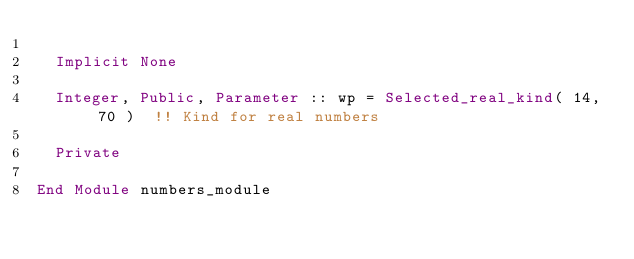<code> <loc_0><loc_0><loc_500><loc_500><_FORTRAN_>  
  Implicit None 
  
  Integer, Public, Parameter :: wp = Selected_real_kind( 14, 70 )  !! Kind for real numbers

  Private
  
End Module numbers_module

</code> 